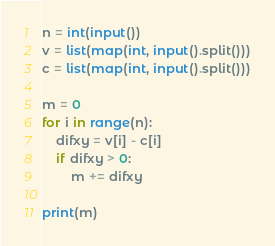Convert code to text. <code><loc_0><loc_0><loc_500><loc_500><_Python_>n = int(input())
v = list(map(int, input().split()))
c = list(map(int, input().split()))

m = 0
for i in range(n):
    difxy = v[i] - c[i]
    if difxy > 0:
        m += difxy

print(m)
</code> 